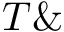<formula> <loc_0><loc_0><loc_500><loc_500>T \&</formula> 